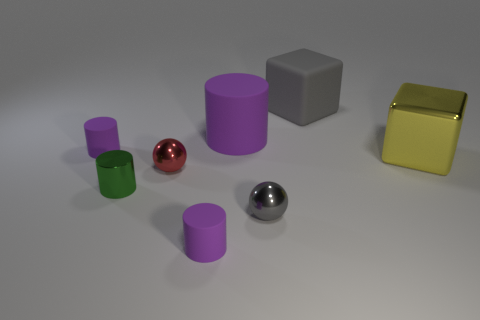Subtract all brown cubes. How many purple cylinders are left? 3 Subtract 1 cylinders. How many cylinders are left? 3 Add 2 large yellow metallic blocks. How many objects exist? 10 Subtract all blocks. How many objects are left? 6 Add 2 big purple cylinders. How many big purple cylinders are left? 3 Add 6 big brown cylinders. How many big brown cylinders exist? 6 Subtract 1 red spheres. How many objects are left? 7 Subtract all large green matte cubes. Subtract all yellow metal objects. How many objects are left? 7 